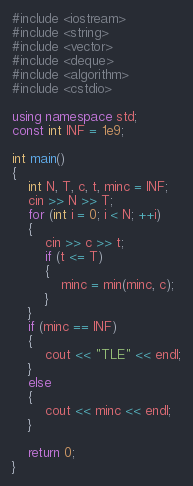<code> <loc_0><loc_0><loc_500><loc_500><_C++_>#include <iostream>
#include <string>
#include <vector>
#include <deque>
#include <algorithm>
#include <cstdio>

using namespace std;
const int INF = 1e9;

int main()
{
    int N, T, c, t, minc = INF;
    cin >> N >> T;
    for (int i = 0; i < N; ++i)
    {
        cin >> c >> t;
        if (t <= T)
        {
            minc = min(minc, c);
        }
    }
    if (minc == INF)
    {
        cout << "TLE" << endl;
    }
    else
    {
        cout << minc << endl;
    }

    return 0;
}
</code> 